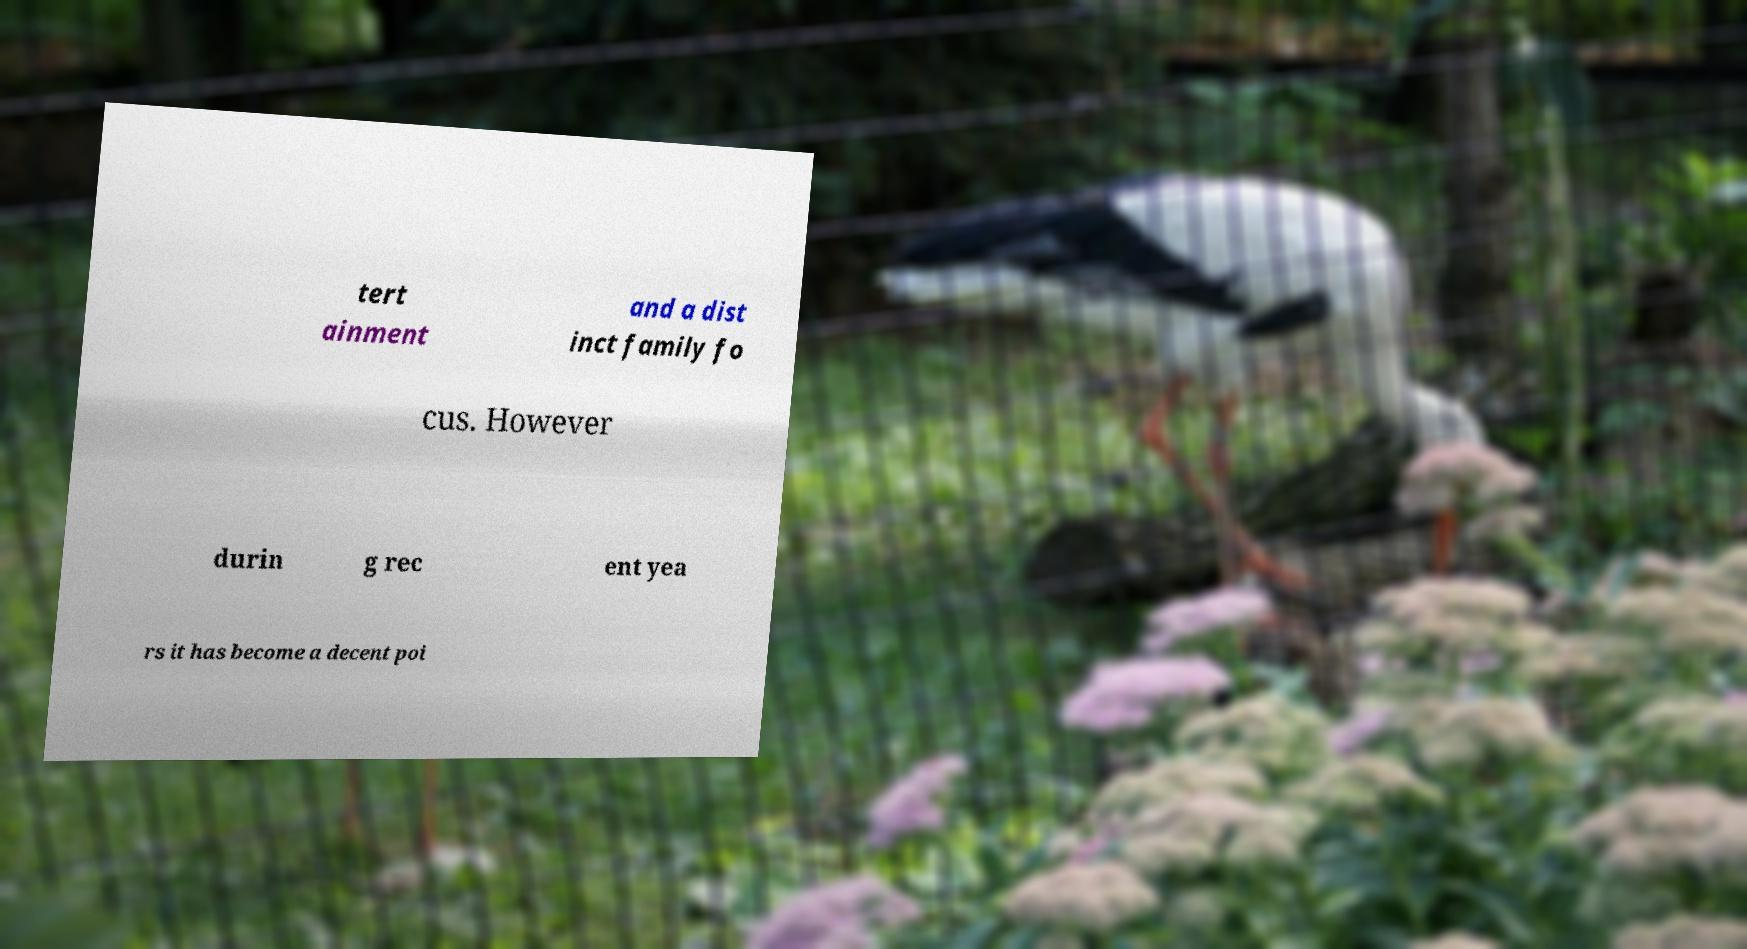There's text embedded in this image that I need extracted. Can you transcribe it verbatim? tert ainment and a dist inct family fo cus. However durin g rec ent yea rs it has become a decent poi 